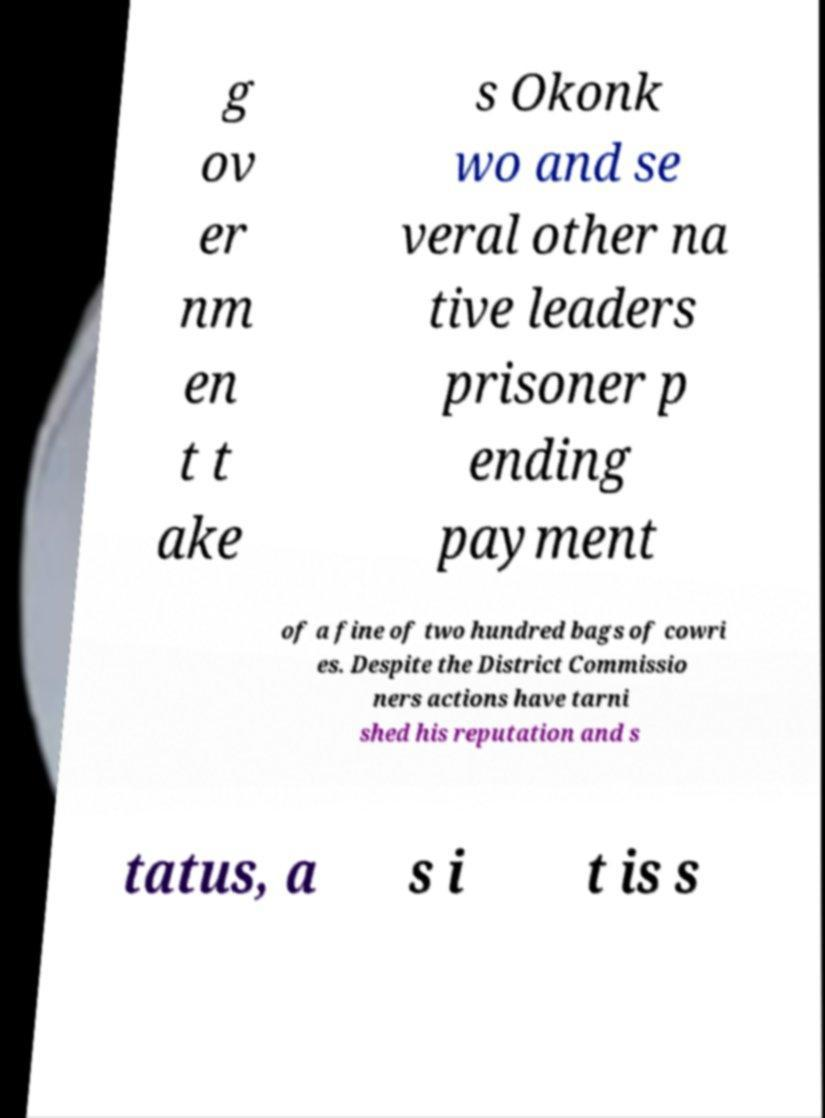Could you extract and type out the text from this image? g ov er nm en t t ake s Okonk wo and se veral other na tive leaders prisoner p ending payment of a fine of two hundred bags of cowri es. Despite the District Commissio ners actions have tarni shed his reputation and s tatus, a s i t is s 